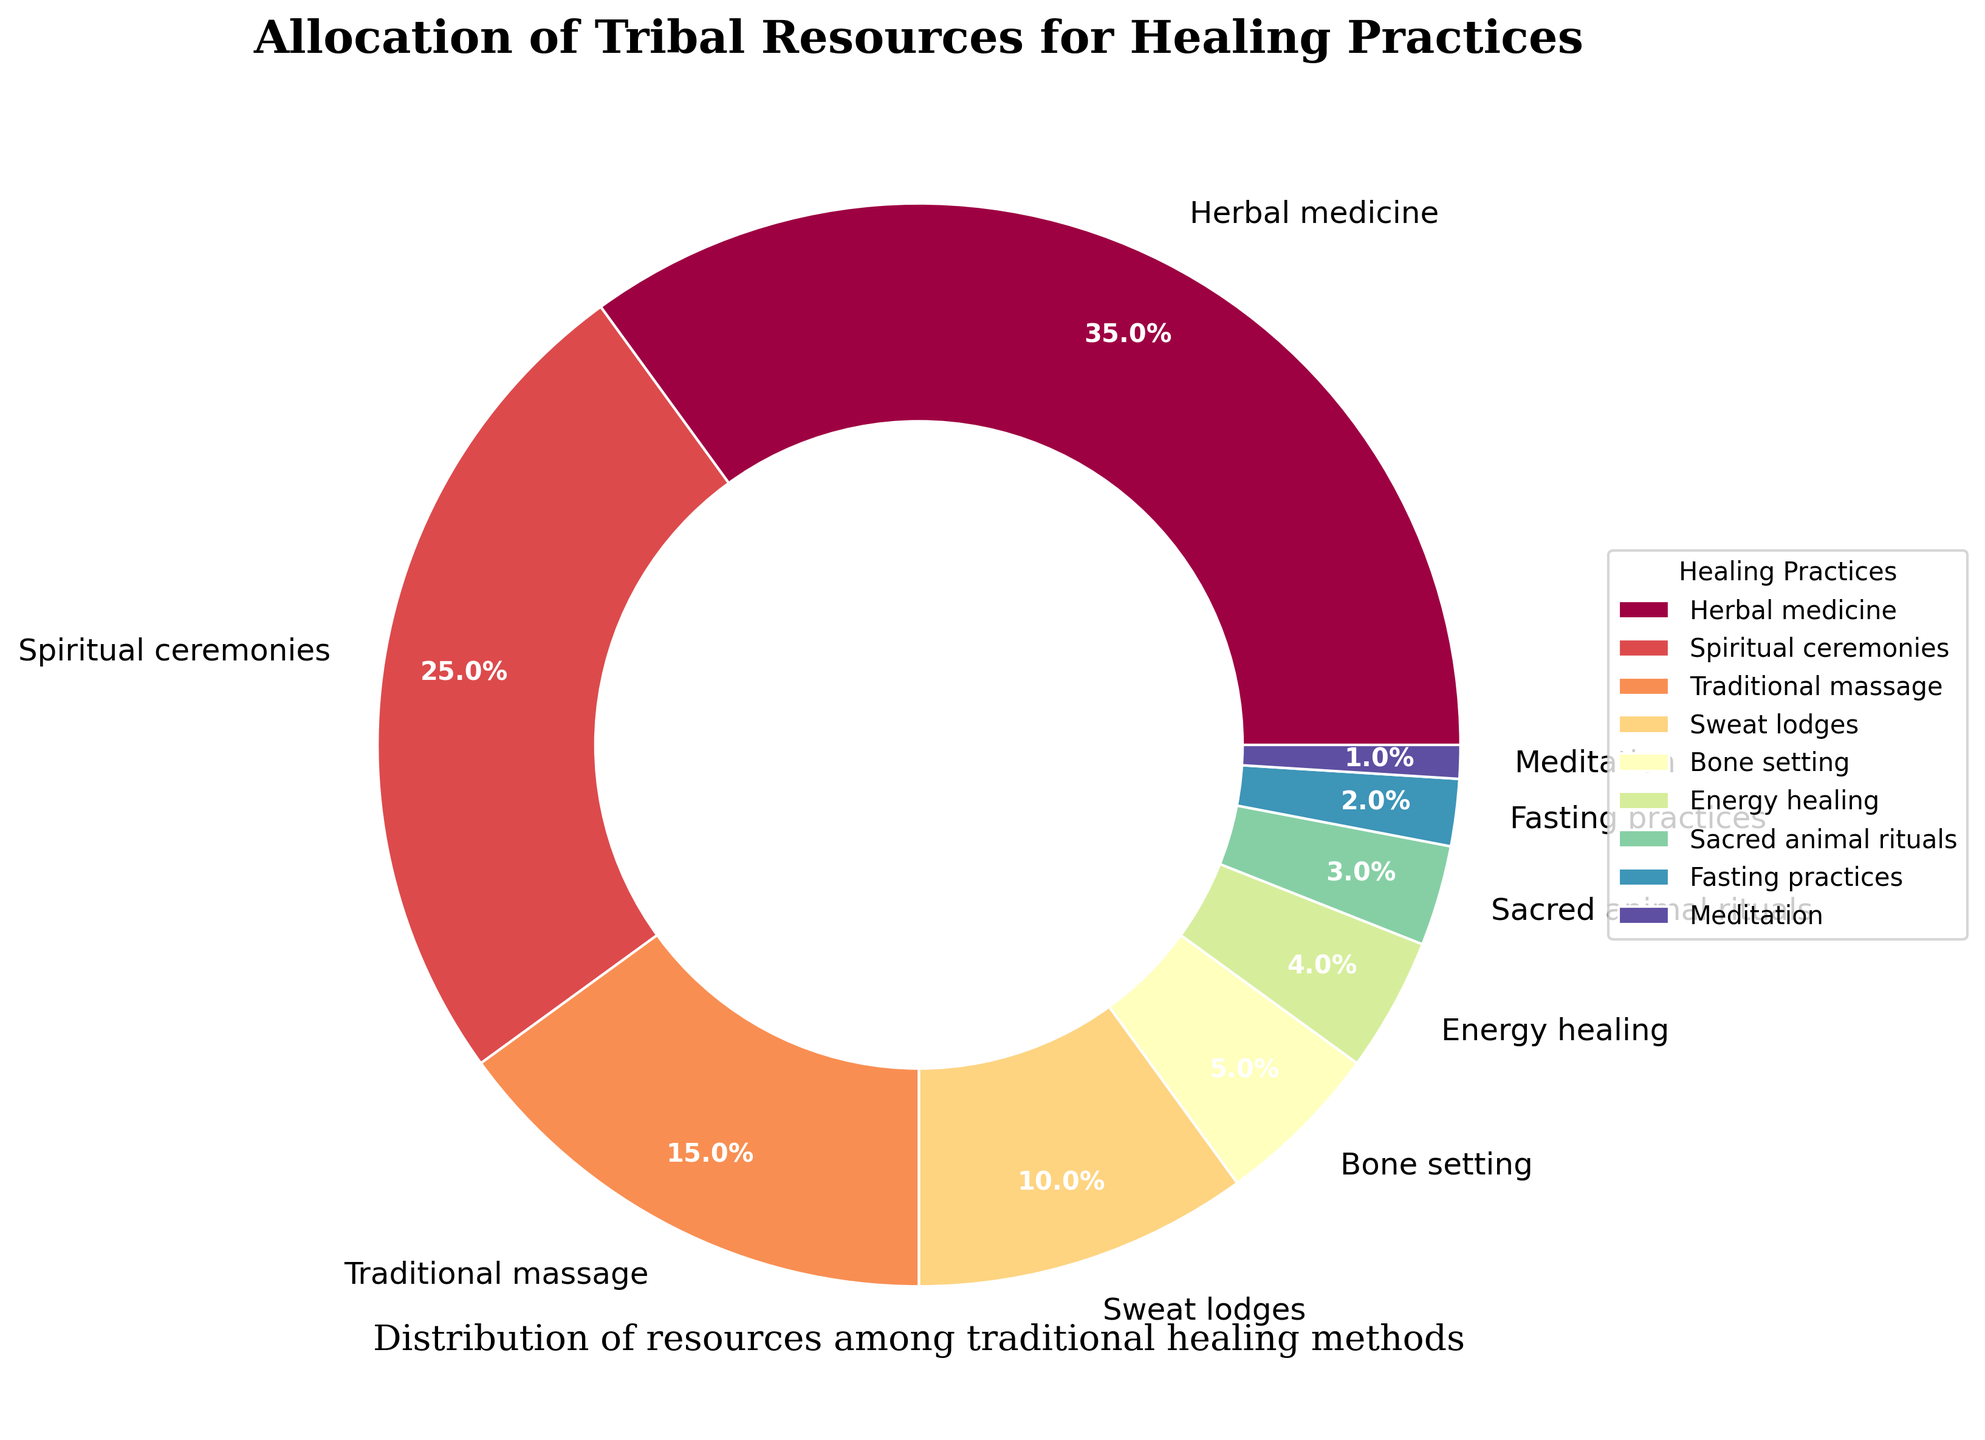What is the largest allocation of resources among the healing practices? The figure shows that the practice with the largest allocation is Herbal medicine, which occupies the biggest segment of the pie chart.
Answer: Herbal medicine Which two practices combined have a resource allocation equal to Spiritual ceremonies? Spiritual ceremonies are allocated 25%. Adding the percentages of Traditional massage (15%) and Sweat lodges (10%) gives us 15% + 10% = 25%.
Answer: Traditional massage and Sweat lodges What is the difference in resource allocation between Traditional massage and Energy healing? Traditional massage is allocated 15%, while Energy healing is allocated 4%. Subtracting these gives us 15% - 4% = 11%.
Answer: 11% Which practice has a smaller allocation of resources, Meditation or Sacred animal rituals? Meditation is allocated 1%, while Sacred animal rituals are allocated 3%.
Answer: Meditation What is the sum of the resource allocations for Bone setting, Energy healing, and Sacred animal rituals? The allocations are 5% for Bone setting, 4% for Energy healing, and 3% for Sacred animal rituals. Summing these gives 5% + 4% + 3% = 12%.
Answer: 12% Among the practices listed, which has the least allocation of tribal resources? The figure shows that Meditation has the smallest segment, indicating the least allocation at 1%.
Answer: Meditation How much greater is the resource allocation for Herbal medicine compared to Sweat lodges? Herbal medicine is allocated 35%, while Sweat lodges are allocated 10%. Subtracting these gives 35% - 10% = 25%.
Answer: 25% What percentage of resources is allocated to practices with less than 5% allocation each? Adding the percentages for Bone setting (5%), Energy healing (4%), Sacred animal rituals (3%), Fasting practices (2%), and Meditation (1%) gives 5% + 4% + 3% + 2% + 1% = 15%.
Answer: 15% Which two practices have the closest allocation percentages? The allocation for Bone setting is 5%, and the allocation for Energy healing is 4%, making their difference 1%, the smallest among all.
Answer: Bone setting and Energy healing 